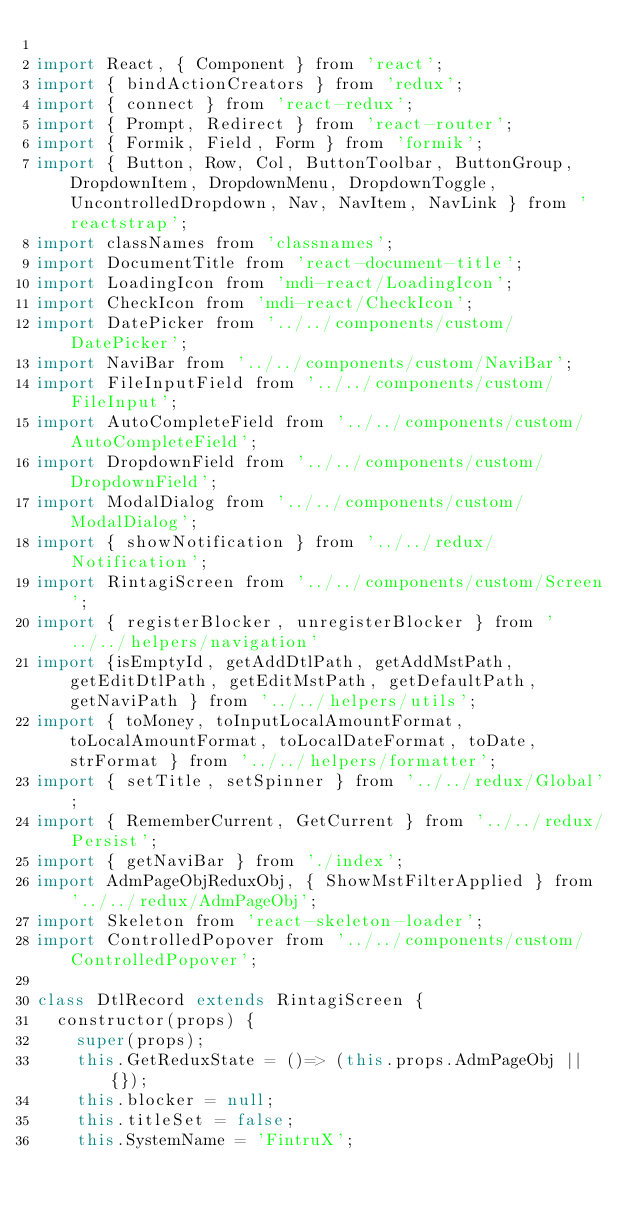Convert code to text. <code><loc_0><loc_0><loc_500><loc_500><_JavaScript_>
import React, { Component } from 'react';
import { bindActionCreators } from 'redux';
import { connect } from 'react-redux';
import { Prompt, Redirect } from 'react-router';
import { Formik, Field, Form } from 'formik';
import { Button, Row, Col, ButtonToolbar, ButtonGroup, DropdownItem, DropdownMenu, DropdownToggle, UncontrolledDropdown, Nav, NavItem, NavLink } from 'reactstrap';
import classNames from 'classnames';
import DocumentTitle from 'react-document-title';
import LoadingIcon from 'mdi-react/LoadingIcon';
import CheckIcon from 'mdi-react/CheckIcon';
import DatePicker from '../../components/custom/DatePicker';
import NaviBar from '../../components/custom/NaviBar';
import FileInputField from '../../components/custom/FileInput';
import AutoCompleteField from '../../components/custom/AutoCompleteField';
import DropdownField from '../../components/custom/DropdownField';
import ModalDialog from '../../components/custom/ModalDialog';
import { showNotification } from '../../redux/Notification';
import RintagiScreen from '../../components/custom/Screen';
import { registerBlocker, unregisterBlocker } from '../../helpers/navigation'
import {isEmptyId, getAddDtlPath, getAddMstPath, getEditDtlPath, getEditMstPath, getDefaultPath, getNaviPath } from '../../helpers/utils';
import { toMoney, toInputLocalAmountFormat, toLocalAmountFormat, toLocalDateFormat, toDate, strFormat } from '../../helpers/formatter';
import { setTitle, setSpinner } from '../../redux/Global';
import { RememberCurrent, GetCurrent } from '../../redux/Persist';
import { getNaviBar } from './index';
import AdmPageObjReduxObj, { ShowMstFilterApplied } from '../../redux/AdmPageObj';
import Skeleton from 'react-skeleton-loader';
import ControlledPopover from '../../components/custom/ControlledPopover';

class DtlRecord extends RintagiScreen {
  constructor(props) {
    super(props);
    this.GetReduxState = ()=> (this.props.AdmPageObj || {});
    this.blocker = null;
    this.titleSet = false;
    this.SystemName = 'FintruX';</code> 